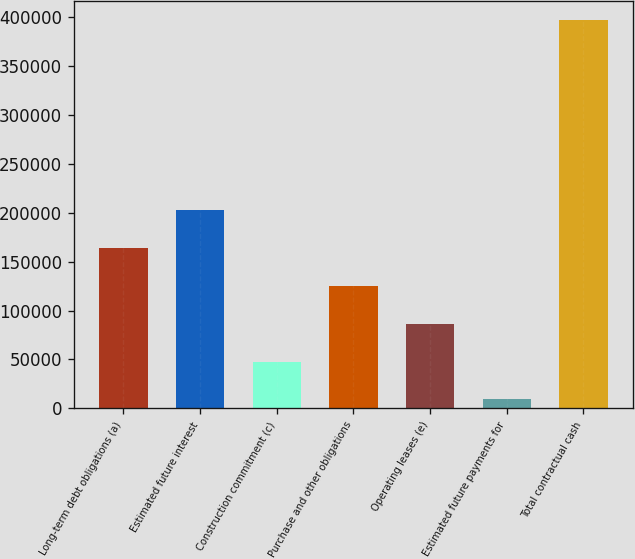Convert chart. <chart><loc_0><loc_0><loc_500><loc_500><bar_chart><fcel>Long-term debt obligations (a)<fcel>Estimated future interest<fcel>Construction commitment (c)<fcel>Purchase and other obligations<fcel>Operating leases (e)<fcel>Estimated future payments for<fcel>Total contractual cash<nl><fcel>164189<fcel>202956<fcel>47888.1<fcel>125422<fcel>86655.2<fcel>9121<fcel>396792<nl></chart> 